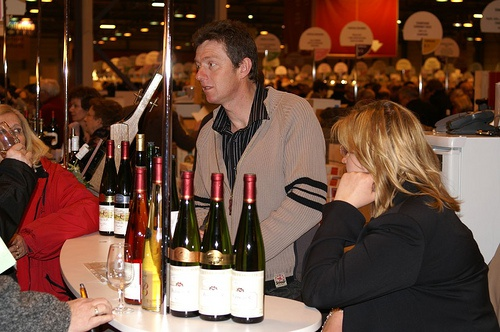Describe the objects in this image and their specific colors. I can see people in brown, black, maroon, and gray tones, people in brown, gray, and black tones, people in brown, maroon, and black tones, bottle in brown, black, white, maroon, and gray tones, and people in brown, gray, and tan tones in this image. 